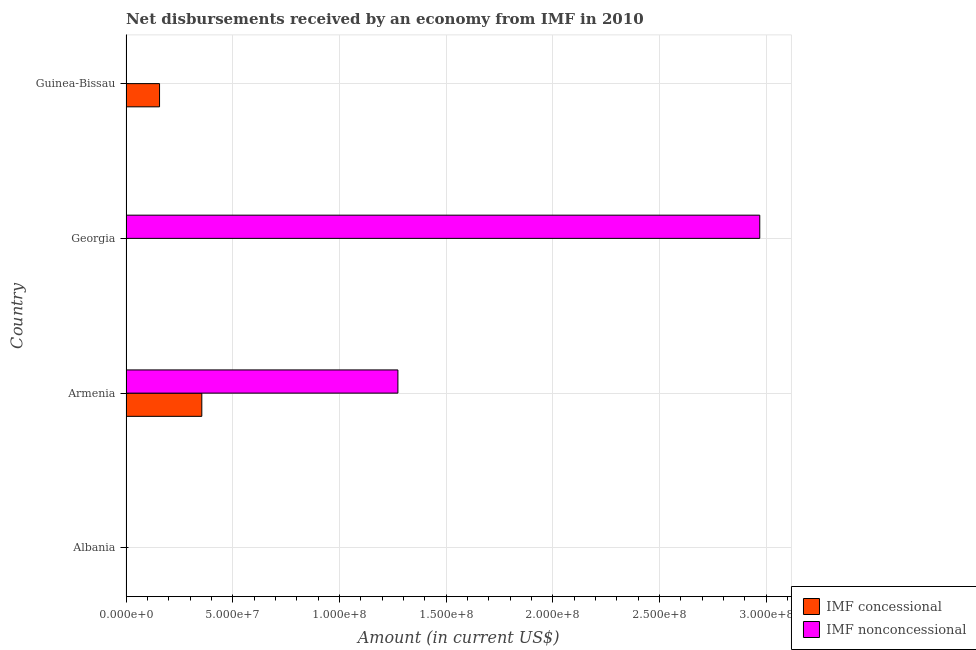Are the number of bars on each tick of the Y-axis equal?
Provide a succinct answer. No. How many bars are there on the 3rd tick from the top?
Provide a short and direct response. 2. What is the label of the 3rd group of bars from the top?
Ensure brevity in your answer.  Armenia. What is the net non concessional disbursements from imf in Albania?
Give a very brief answer. 0. Across all countries, what is the maximum net non concessional disbursements from imf?
Provide a succinct answer. 2.97e+08. In which country was the net non concessional disbursements from imf maximum?
Offer a very short reply. Georgia. What is the total net non concessional disbursements from imf in the graph?
Your answer should be compact. 4.24e+08. What is the difference between the net non concessional disbursements from imf in Armenia and that in Georgia?
Provide a short and direct response. -1.70e+08. What is the difference between the net non concessional disbursements from imf in Georgia and the net concessional disbursements from imf in Armenia?
Provide a short and direct response. 2.61e+08. What is the average net concessional disbursements from imf per country?
Your response must be concise. 1.28e+07. What is the difference between the net concessional disbursements from imf and net non concessional disbursements from imf in Armenia?
Your answer should be very brief. -9.19e+07. In how many countries, is the net non concessional disbursements from imf greater than 220000000 US$?
Offer a terse response. 1. What is the ratio of the net concessional disbursements from imf in Armenia to that in Guinea-Bissau?
Your answer should be compact. 2.26. What is the difference between the highest and the lowest net concessional disbursements from imf?
Offer a very short reply. 3.55e+07. In how many countries, is the net concessional disbursements from imf greater than the average net concessional disbursements from imf taken over all countries?
Your answer should be compact. 2. Are all the bars in the graph horizontal?
Offer a terse response. Yes. How many countries are there in the graph?
Give a very brief answer. 4. What is the difference between two consecutive major ticks on the X-axis?
Your response must be concise. 5.00e+07. Are the values on the major ticks of X-axis written in scientific E-notation?
Provide a short and direct response. Yes. Does the graph contain grids?
Offer a very short reply. Yes. Where does the legend appear in the graph?
Ensure brevity in your answer.  Bottom right. How many legend labels are there?
Offer a terse response. 2. What is the title of the graph?
Your answer should be very brief. Net disbursements received by an economy from IMF in 2010. Does "Merchandise imports" appear as one of the legend labels in the graph?
Keep it short and to the point. No. What is the Amount (in current US$) of IMF concessional in Albania?
Provide a succinct answer. 0. What is the Amount (in current US$) of IMF nonconcessional in Albania?
Give a very brief answer. 0. What is the Amount (in current US$) of IMF concessional in Armenia?
Provide a succinct answer. 3.55e+07. What is the Amount (in current US$) in IMF nonconcessional in Armenia?
Make the answer very short. 1.27e+08. What is the Amount (in current US$) in IMF concessional in Georgia?
Your answer should be very brief. 0. What is the Amount (in current US$) in IMF nonconcessional in Georgia?
Your response must be concise. 2.97e+08. What is the Amount (in current US$) of IMF concessional in Guinea-Bissau?
Provide a succinct answer. 1.57e+07. Across all countries, what is the maximum Amount (in current US$) in IMF concessional?
Your answer should be compact. 3.55e+07. Across all countries, what is the maximum Amount (in current US$) in IMF nonconcessional?
Provide a succinct answer. 2.97e+08. What is the total Amount (in current US$) of IMF concessional in the graph?
Provide a succinct answer. 5.12e+07. What is the total Amount (in current US$) in IMF nonconcessional in the graph?
Your answer should be very brief. 4.24e+08. What is the difference between the Amount (in current US$) of IMF nonconcessional in Armenia and that in Georgia?
Offer a terse response. -1.70e+08. What is the difference between the Amount (in current US$) of IMF concessional in Armenia and that in Guinea-Bissau?
Offer a very short reply. 1.98e+07. What is the difference between the Amount (in current US$) of IMF concessional in Armenia and the Amount (in current US$) of IMF nonconcessional in Georgia?
Offer a very short reply. -2.61e+08. What is the average Amount (in current US$) of IMF concessional per country?
Give a very brief answer. 1.28e+07. What is the average Amount (in current US$) of IMF nonconcessional per country?
Keep it short and to the point. 1.06e+08. What is the difference between the Amount (in current US$) of IMF concessional and Amount (in current US$) of IMF nonconcessional in Armenia?
Your response must be concise. -9.19e+07. What is the ratio of the Amount (in current US$) of IMF nonconcessional in Armenia to that in Georgia?
Your answer should be very brief. 0.43. What is the ratio of the Amount (in current US$) of IMF concessional in Armenia to that in Guinea-Bissau?
Provide a short and direct response. 2.26. What is the difference between the highest and the lowest Amount (in current US$) in IMF concessional?
Your answer should be very brief. 3.55e+07. What is the difference between the highest and the lowest Amount (in current US$) of IMF nonconcessional?
Ensure brevity in your answer.  2.97e+08. 